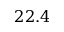<formula> <loc_0><loc_0><loc_500><loc_500>2 2 . 4</formula> 